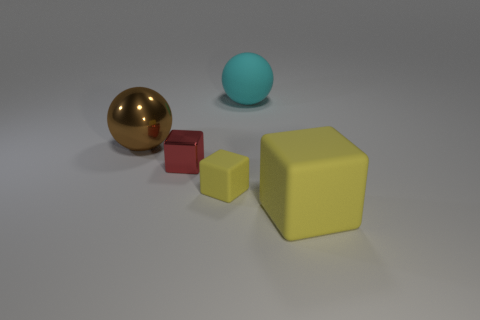Is the size of the matte object behind the red thing the same as the metal cube?
Offer a very short reply. No. Is the number of red cubes that are to the right of the big brown ball less than the number of tiny rubber objects?
Offer a terse response. No. Is there anything else that is the same size as the red shiny thing?
Provide a succinct answer. Yes. There is a metal object on the left side of the metal thing that is in front of the shiny sphere; what size is it?
Your answer should be very brief. Large. Is there anything else that has the same shape as the tiny rubber object?
Ensure brevity in your answer.  Yes. Are there fewer big cyan metal blocks than yellow objects?
Your answer should be compact. Yes. There is a thing that is both behind the red block and on the right side of the metallic sphere; what material is it?
Provide a short and direct response. Rubber. There is a large object to the left of the red metallic cube; are there any big brown shiny objects to the right of it?
Provide a short and direct response. No. How many things are large rubber things or cyan matte things?
Provide a short and direct response. 2. What shape is the large object that is both in front of the large cyan rubber ball and on the right side of the big brown sphere?
Make the answer very short. Cube. 